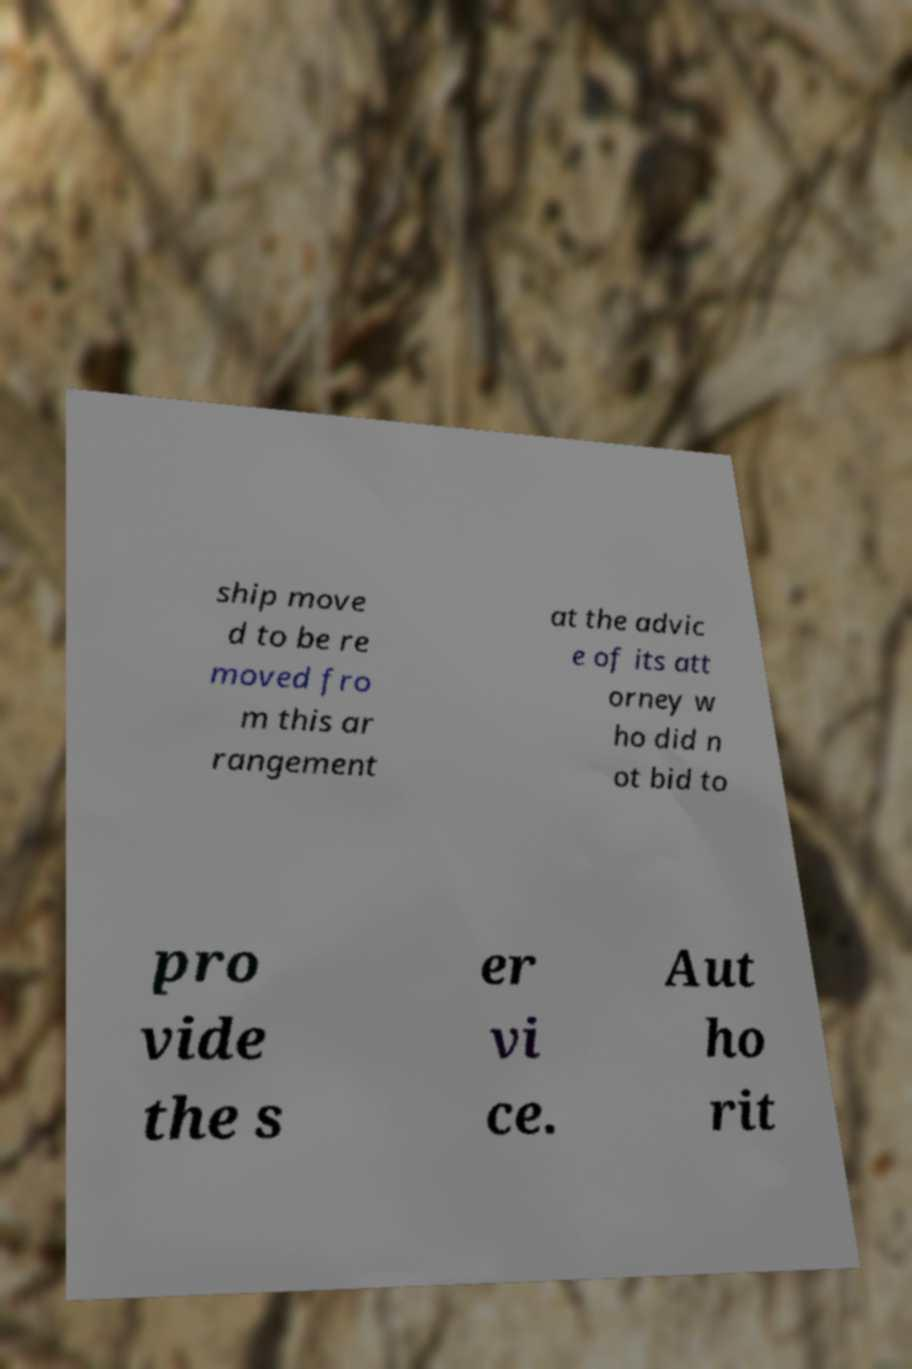What messages or text are displayed in this image? I need them in a readable, typed format. ship move d to be re moved fro m this ar rangement at the advic e of its att orney w ho did n ot bid to pro vide the s er vi ce. Aut ho rit 